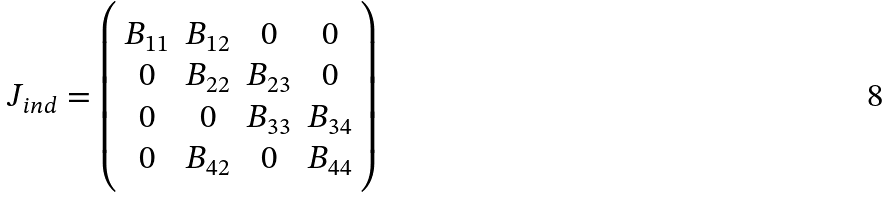Convert formula to latex. <formula><loc_0><loc_0><loc_500><loc_500>J _ { i n d } = \left ( \begin{array} { c c c c } B _ { 1 1 } & B _ { 1 2 } & 0 & 0 \\ 0 & B _ { 2 2 } & B _ { 2 3 } & 0 \\ 0 & 0 & B _ { 3 3 } & B _ { 3 4 } \\ 0 & B _ { 4 2 } & 0 & B _ { 4 4 } \\ \end{array} \right )</formula> 